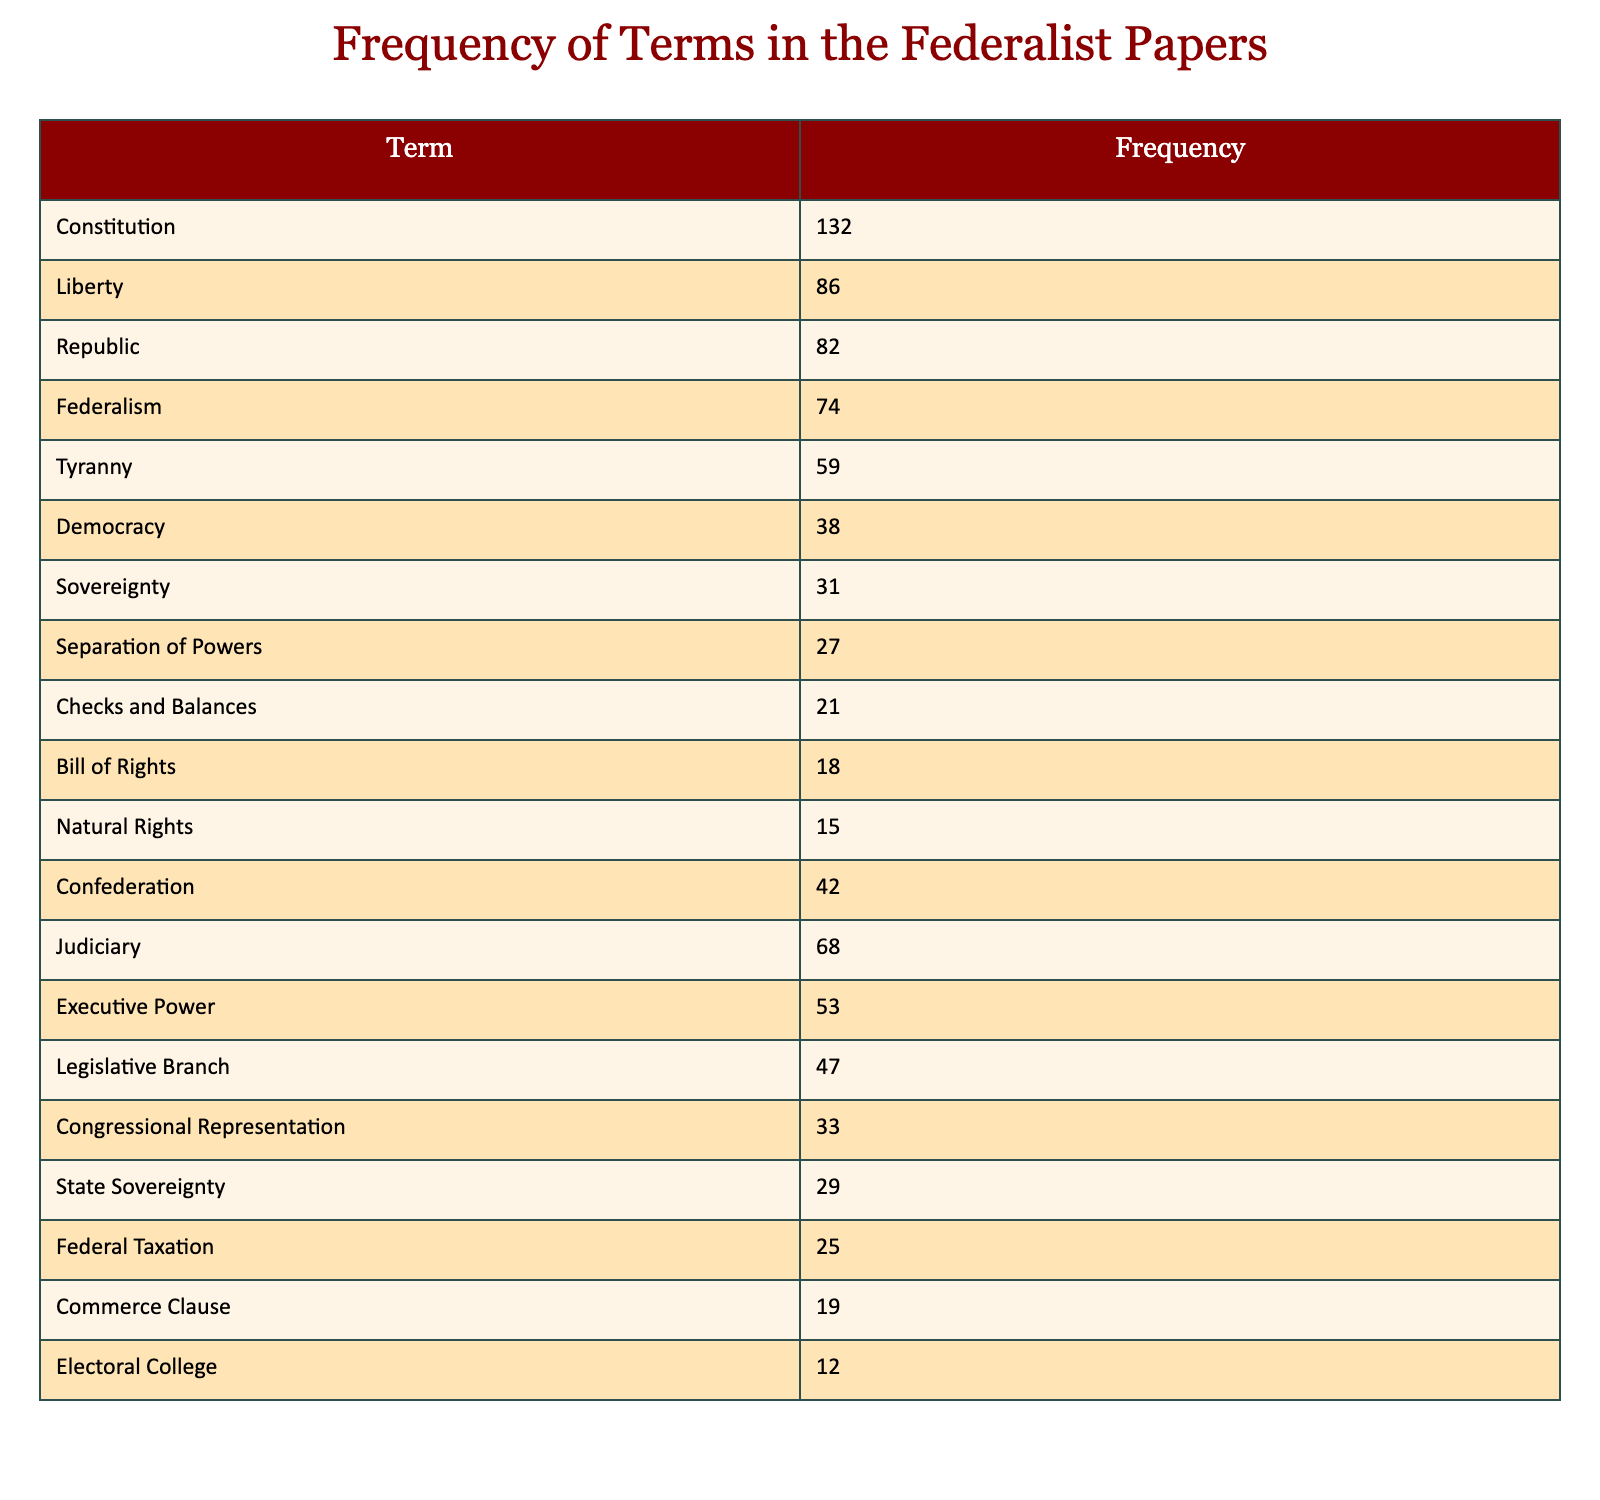What is the frequency of the term "Liberty"? The table directly lists the frequency of the term "Liberty" under the "Frequency" column, which shows it is 86.
Answer: 86 Which term has the highest frequency? By comparing the values in the "Frequency" column, "Constitution" has the highest count at 132.
Answer: Constitution What is the total frequency of terms related to government structures (e.g., "Executive Power," "Judiciary," "Legislative Branch")? To find this total, we sum the frequencies of the relevant terms: Executive Power (53) + Judiciary (68) + Legislative Branch (47) = 53 + 68 + 47 = 168.
Answer: 168 Is the term "Bill of Rights" used more frequently than "Checks and Balances"? The table shows "Bill of Rights" has a frequency of 18 and "Checks and Balances" has 21; thus, "Bill of Rights" is used less frequently than "Checks and Balances."
Answer: No What is the average frequency of terms related to government powers ("Executive Power," "Judiciary," "Legislative Branch," "Congressional Representation," "Federal Taxation")? First, we list the frequencies of the terms: Executive Power (53), Judiciary (68), Legislative Branch (47), Congressional Representation (33), Federal Taxation (25). Then, we sum them: 53 + 68 + 47 + 33 + 25 = 226. There are 5 terms, so the average is 226/5 = 45.2.
Answer: 45.2 How many terms have a frequency greater than 50? The terms that have a frequency greater than 50 are "Constitution" (132), "Liberty" (86), "Judiciary" (68), "Executive Power" (53), and "Federalism" (74). Counting these gives us 5 terms.
Answer: 5 What is the frequency difference between "Tyranny" and "Democracy"? The frequency of "Tyranny" is 59, and "Democracy" is 38. The difference is calculated as 59 - 38 = 21.
Answer: 21 Which terms are associated with lower frequencies, under 20? Looking through the table, the terms that have a frequency of less than 20 are "Electoral College" (12) and "Commerce Clause" (19), so there are 2 such terms.
Answer: 2 What percentage of the total frequency does the term "Federalism" represent? First, we sum all frequencies to get the total: 132 + 86 + 82 + 74 + 59 + 38 + 31 + 27 + 21 + 18 + 15 + 42 + 68 + 53 + 47 + 33 + 29 + 25 + 19 + 12 = 682. "Federalism" has a frequency of 74. The percentage is (74/682) * 100 ≈ 10.85%.
Answer: 10.85% 